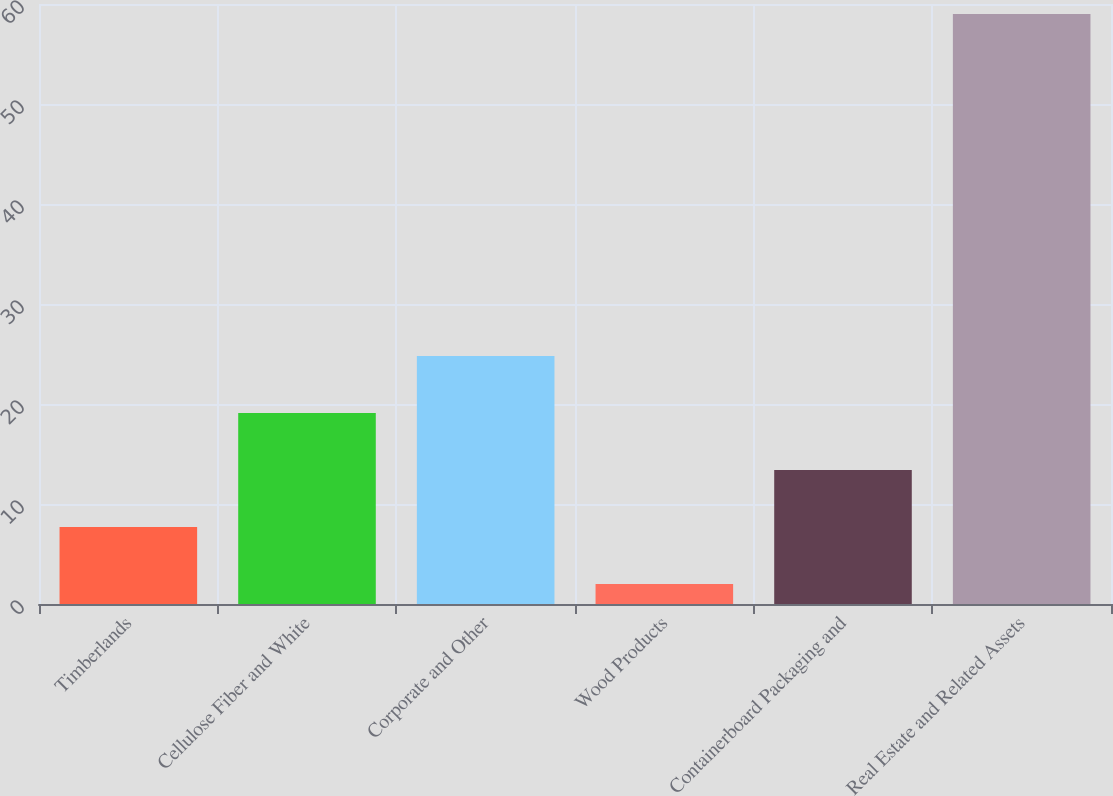Convert chart to OTSL. <chart><loc_0><loc_0><loc_500><loc_500><bar_chart><fcel>Timberlands<fcel>Cellulose Fiber and White<fcel>Corporate and Other<fcel>Wood Products<fcel>Containerboard Packaging and<fcel>Real Estate and Related Assets<nl><fcel>7.7<fcel>19.1<fcel>24.8<fcel>2<fcel>13.4<fcel>59<nl></chart> 